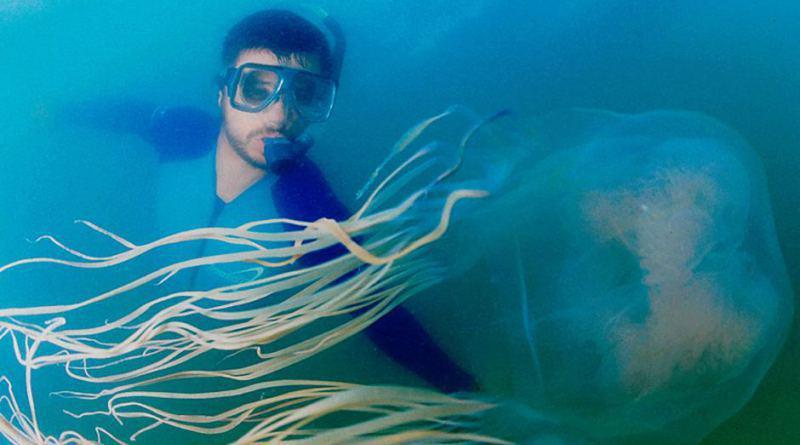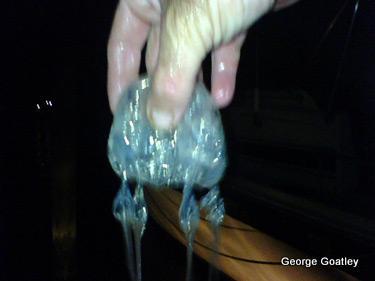The first image is the image on the left, the second image is the image on the right. Assess this claim about the two images: "There is scuba diver in the image on the right.". Correct or not? Answer yes or no. No. The first image is the image on the left, the second image is the image on the right. Examine the images to the left and right. Is the description "Left image includes a diver wearing goggles." accurate? Answer yes or no. Yes. 